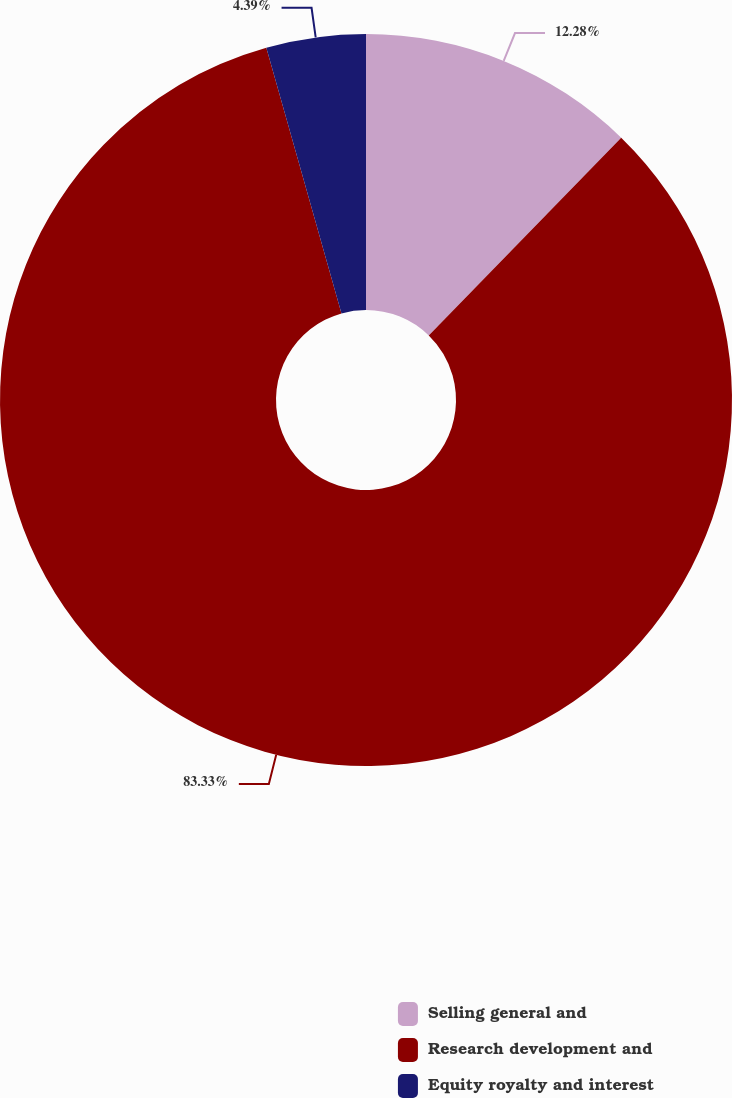<chart> <loc_0><loc_0><loc_500><loc_500><pie_chart><fcel>Selling general and<fcel>Research development and<fcel>Equity royalty and interest<nl><fcel>12.28%<fcel>83.33%<fcel>4.39%<nl></chart> 